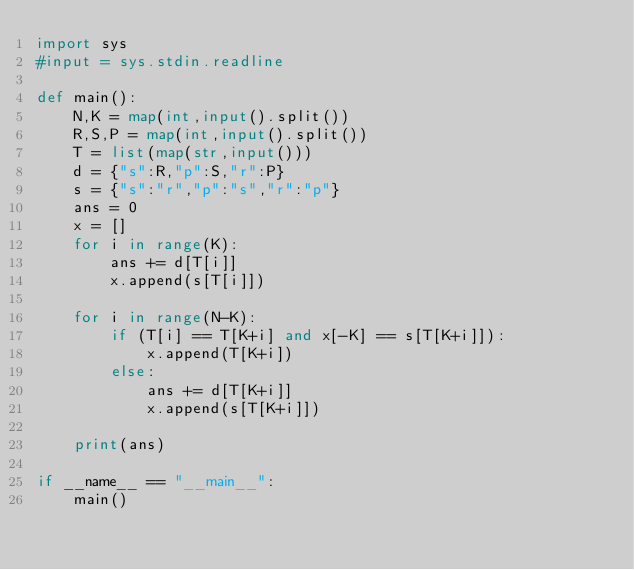Convert code to text. <code><loc_0><loc_0><loc_500><loc_500><_Python_>import sys
#input = sys.stdin.readline

def main():
    N,K = map(int,input().split())
    R,S,P = map(int,input().split())
    T = list(map(str,input()))
    d = {"s":R,"p":S,"r":P}
    s = {"s":"r","p":"s","r":"p"}
    ans = 0
    x = []
    for i in range(K):
        ans += d[T[i]]
        x.append(s[T[i]])

    for i in range(N-K):
        if (T[i] == T[K+i] and x[-K] == s[T[K+i]]):
            x.append(T[K+i])
        else:
            ans += d[T[K+i]]
            x.append(s[T[K+i]])
            
    print(ans)

if __name__ == "__main__":
    main()
</code> 